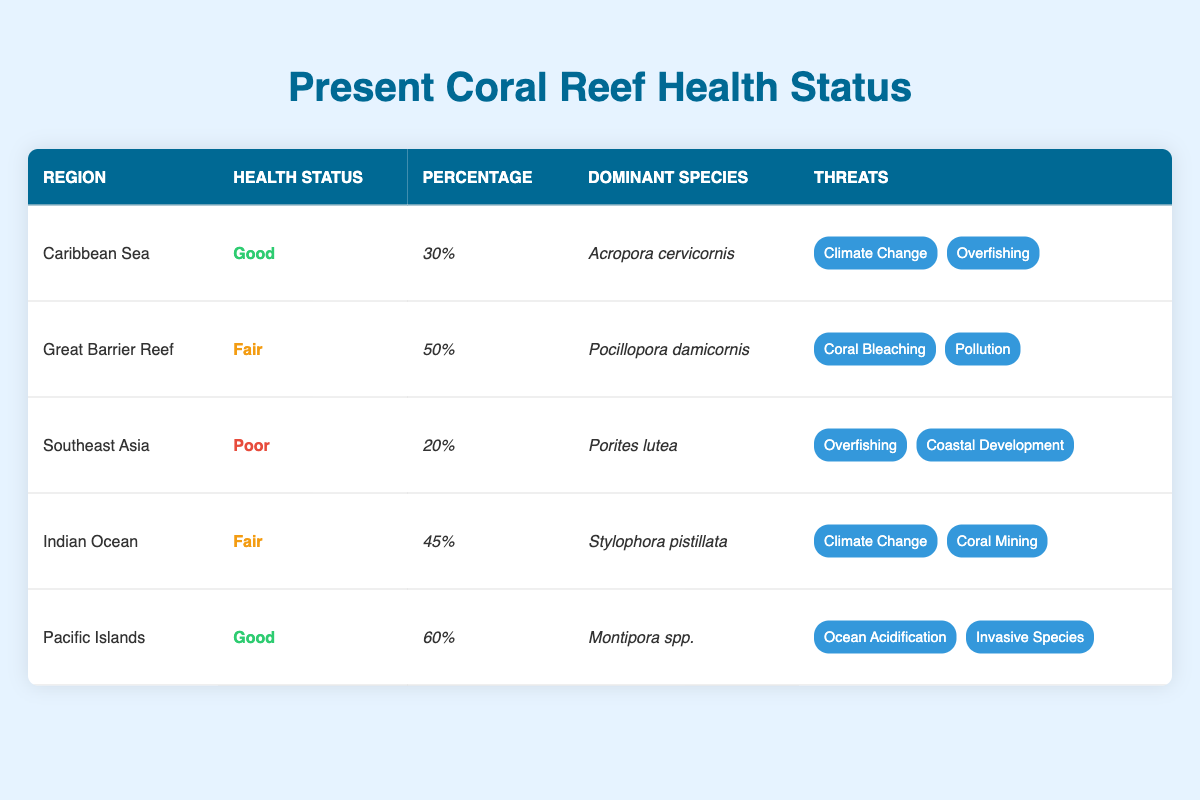What is the health status of the Pacific Islands? From the table, in the row corresponding to the Pacific Islands, the health status is labeled as "Good."
Answer: Good Which region has the highest percentage of coral reef health? Examining the percentages across the regions, the Pacific Islands has the highest value at 60%.
Answer: 60% Are there any regions with a health status of "Poor"? Looking at the health statuses in the table, Southeast Asia is the only region that has a status of "Poor."
Answer: Yes What is the dominant species in the Caribbean Sea? In the entry for the Caribbean Sea, the dominant species is listed as "Acropora cervicornis."
Answer: Acropora cervicornis What is the average percentage of health status for all regions? First, we sum the percentages: 30 + 50 + 20 + 45 + 60 = 205. There are 5 regions, so the average is 205 / 5 = 41.
Answer: 41 Which threats are identified for the Indian Ocean region? Referring to the threats listed for the Indian Ocean in the table, they are "Climate Change" and "Coral Mining."
Answer: Climate Change, Coral Mining In how many regions is "Climate Change" listed as a threat? Checking the threats column, "Climate Change" appears in the Caribbean Sea and Indian Ocean assessments, which accounts for 2 regions.
Answer: 2 regions What is the difference in health status percentage between the Caribbean Sea and Great Barrier Reef? The Caribbean Sea has a percentage of 30%, while the Great Barrier Reef has 50%. The difference is 50 - 30 = 20.
Answer: 20 Name the region with "Coral Bleaching" as a threat. By reviewing the table, "Coral Bleaching" is listed as a threat for the Great Barrier Reef.
Answer: Great Barrier Reef 